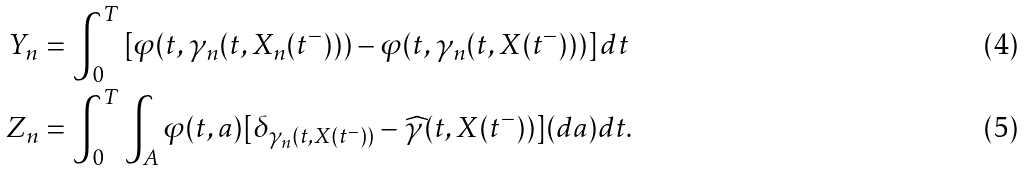Convert formula to latex. <formula><loc_0><loc_0><loc_500><loc_500>Y _ { n } & = \int _ { 0 } ^ { T } \left [ \varphi ( t , \gamma _ { n } ( t , X _ { n } ( t ^ { - } ) ) ) - \varphi ( t , \gamma _ { n } ( t , X ( t ^ { - } ) ) ) \right ] d t \\ Z _ { n } & = \int _ { 0 } ^ { T } \int _ { A } \varphi ( t , a ) [ \delta _ { \gamma _ { n } ( t , X ( t ^ { - } ) ) } - \widehat { \gamma } ( t , X ( t ^ { - } ) ) ] ( d a ) d t .</formula> 